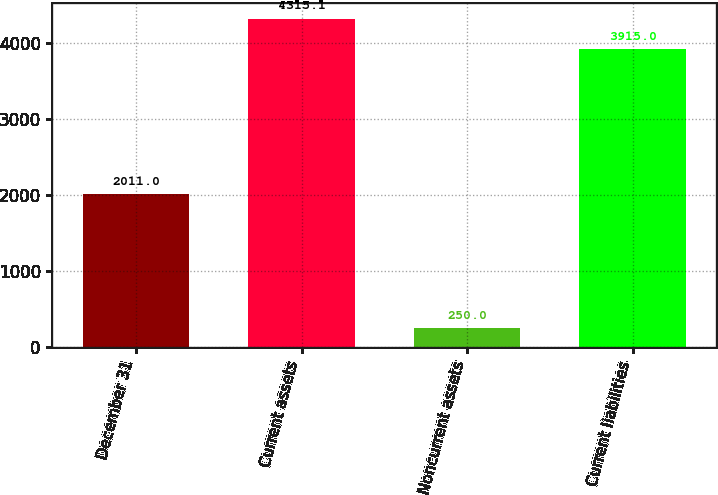Convert chart. <chart><loc_0><loc_0><loc_500><loc_500><bar_chart><fcel>December 31<fcel>Current assets<fcel>Noncurrent assets<fcel>Current liabilities<nl><fcel>2011<fcel>4315.1<fcel>250<fcel>3915<nl></chart> 